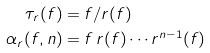<formula> <loc_0><loc_0><loc_500><loc_500>\tau _ { r } ( f ) & = f / r ( f ) \\ \alpha _ { r } ( f , n ) & = f \, r ( f ) \cdots r ^ { n - 1 } ( f )</formula> 